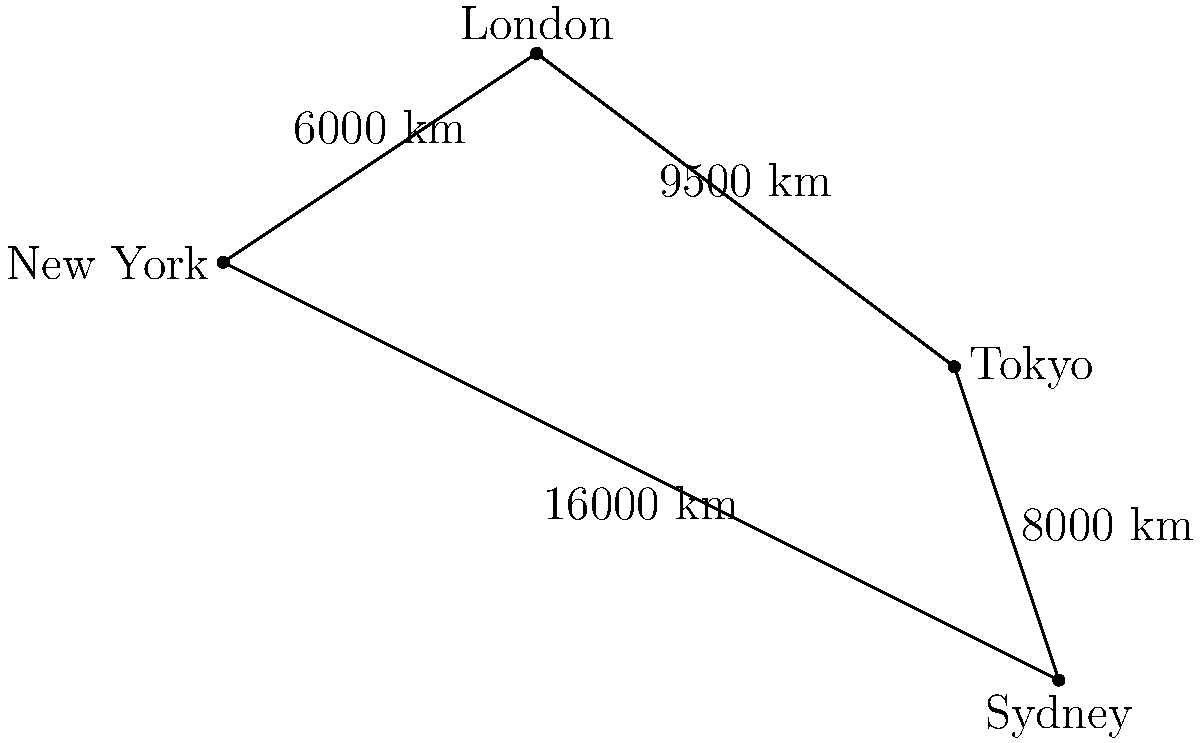You're planning a global adventure to escape your mundane college life. Using the world map provided, estimate the total travel time for a journey from New York to London, then to Tokyo, and finally to Sydney, assuming an average flight speed of 800 km/h and a 2-hour layover at each city. How many hours would this trip take? Let's break this down step-by-step:

1. Calculate the flight times:
   - New York to London: $\frac{6000 \text{ km}}{800 \text{ km/h}} = 7.5$ hours
   - London to Tokyo: $\frac{9500 \text{ km}}{800 \text{ km/h}} = 11.875$ hours
   - Tokyo to Sydney: $\frac{8000 \text{ km}}{800 \text{ km/h}} = 10$ hours

2. Sum up the flight times:
   $7.5 + 11.875 + 10 = 29.375$ hours

3. Add layover times:
   There are 3 layovers (London, Tokyo, Sydney) at 2 hours each:
   $3 \times 2 = 6$ hours

4. Calculate total trip time:
   Flight time + Layover time = $29.375 + 6 = 35.375$ hours

5. Round to the nearest hour:
   $35.375$ rounds to $35$ hours
Answer: 35 hours 